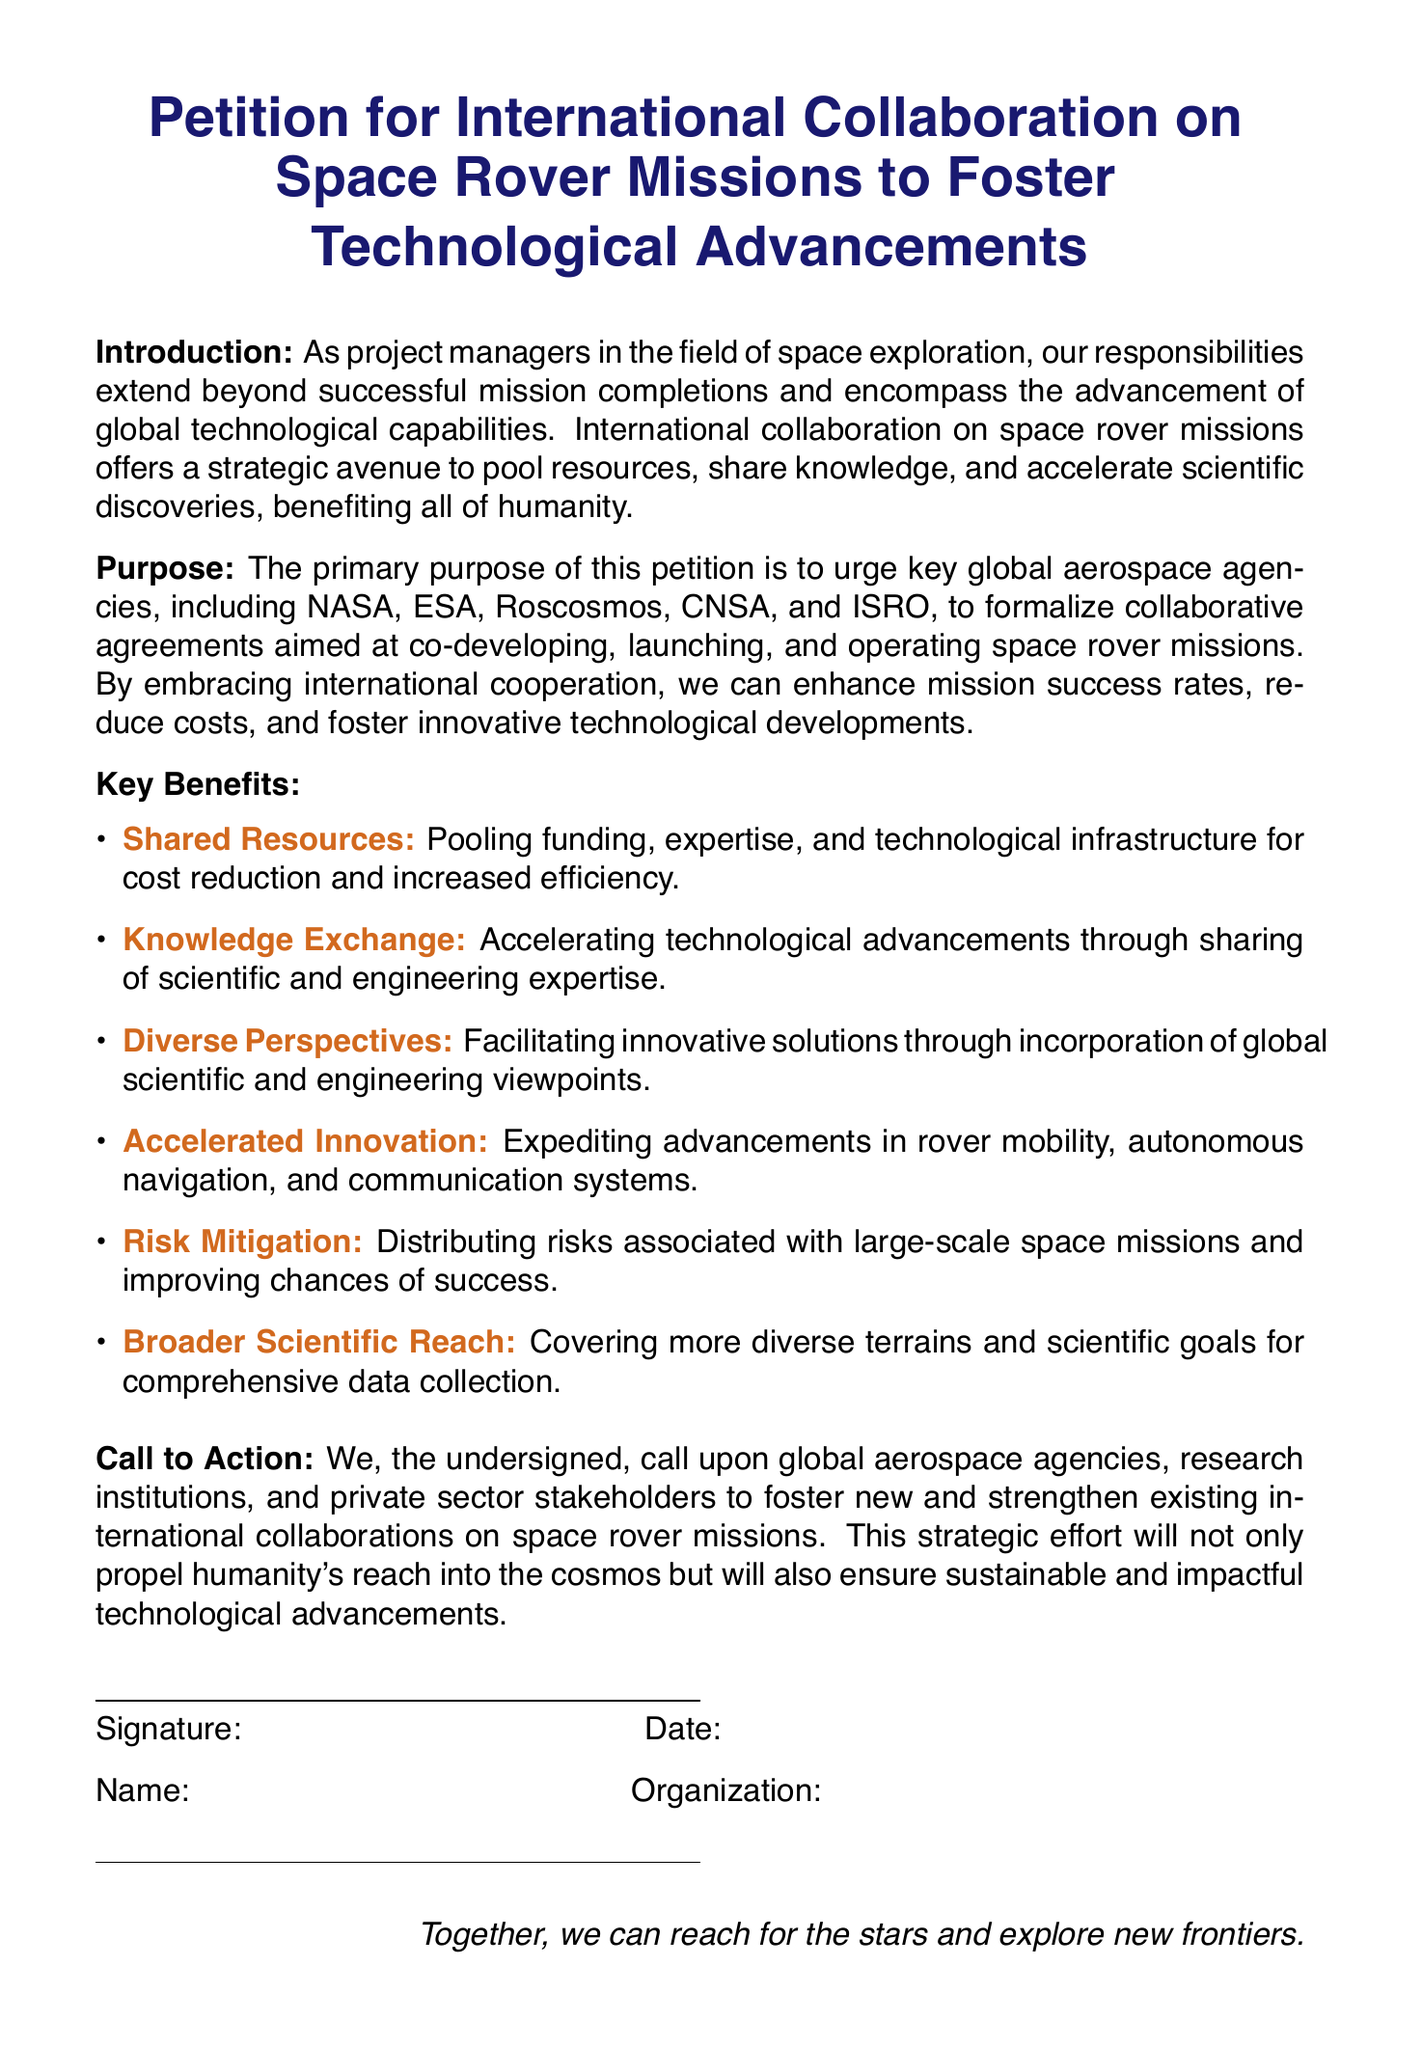What is the primary purpose of the petition? The primary purpose is to urge global aerospace agencies to formalize collaborative agreements for co-developing space rover missions.
Answer: Co-developing space rover missions Which organizations are called upon in the petition? The petition calls upon key global aerospace agencies including NASA, ESA, Roscosmos, CNSA, and ISRO.
Answer: NASA, ESA, Roscosmos, CNSA, ISRO What is one key benefit mentioned regarding shared resources? The petition states that pooling funding, expertise, and technological infrastructure leads to cost reduction and increased efficiency.
Answer: Cost reduction and increased efficiency How many key benefits are listed in the document? The document lists six key benefits of international collaboration on space rover missions.
Answer: Six What is the concluding statement in the document? The statement emphasizes a collective effort to reach for the stars and explore new frontiers.
Answer: Together, we can reach for the stars and explore new frontiers What color is used for the section titles in the document? The section titles are colored in a shade referred to as space blue.
Answer: Space blue What is the title of the document? The title is "Petition for International Collaboration on Space Rover Missions to Foster Technological Advancements."
Answer: Petition for International Collaboration on Space Rover Missions to Foster Technological Advancements What type of document is this? The document is a petition addressing international collaboration in space exploration.
Answer: Petition 